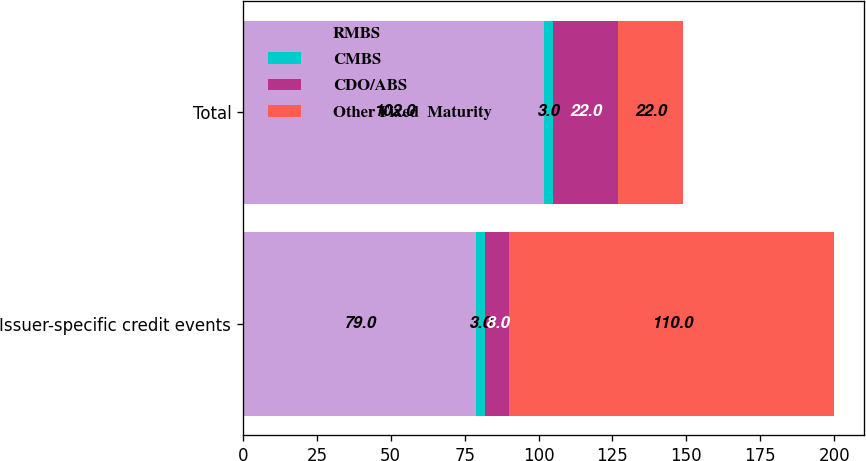Convert chart to OTSL. <chart><loc_0><loc_0><loc_500><loc_500><stacked_bar_chart><ecel><fcel>Issuer-specific credit events<fcel>Total<nl><fcel>RMBS<fcel>79<fcel>102<nl><fcel>CMBS<fcel>3<fcel>3<nl><fcel>CDO/ABS<fcel>8<fcel>22<nl><fcel>Other Fixed  Maturity<fcel>110<fcel>22<nl></chart> 